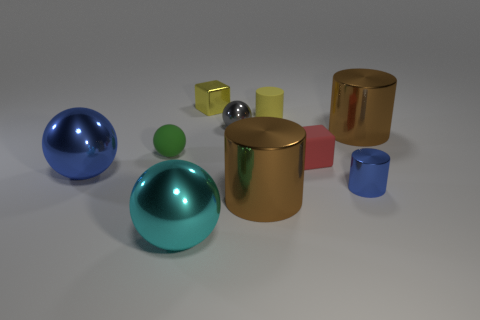Subtract all blue blocks. How many brown cylinders are left? 2 Subtract all large cyan spheres. How many spheres are left? 3 Subtract all gray spheres. How many spheres are left? 3 Subtract all cylinders. How many objects are left? 6 Subtract 1 blue balls. How many objects are left? 9 Subtract all yellow cylinders. Subtract all red cubes. How many cylinders are left? 3 Subtract all blue cylinders. Subtract all rubber blocks. How many objects are left? 8 Add 1 rubber balls. How many rubber balls are left? 2 Add 1 tiny green rubber spheres. How many tiny green rubber spheres exist? 2 